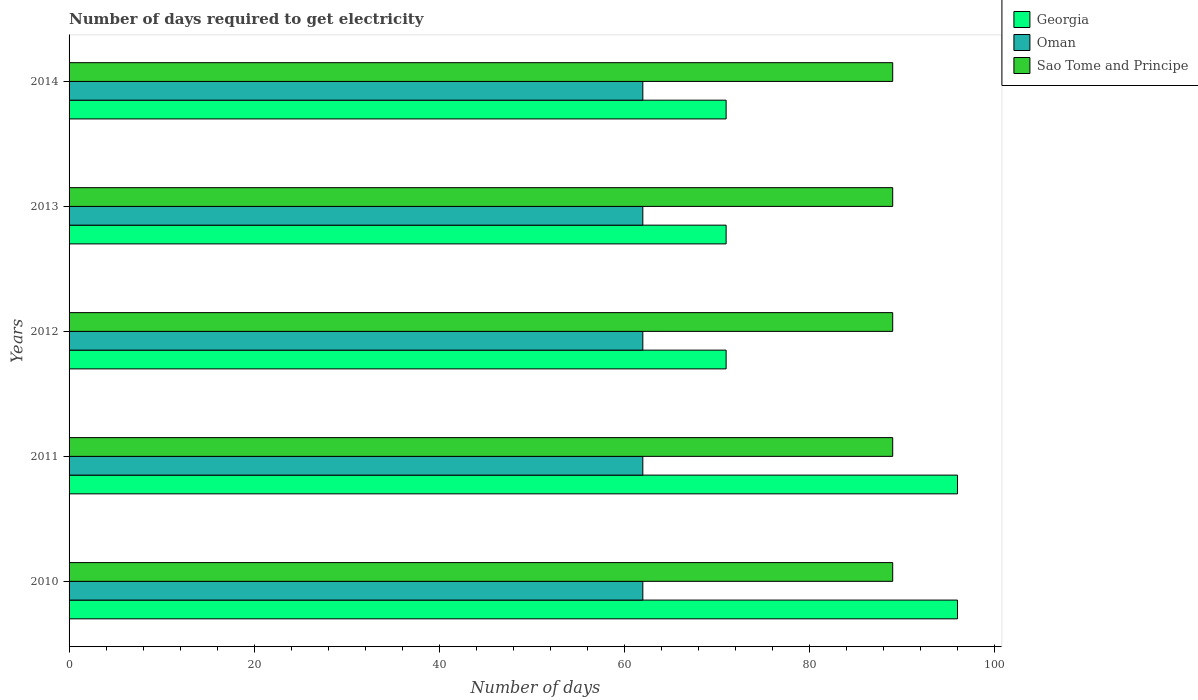How many groups of bars are there?
Keep it short and to the point. 5. Are the number of bars per tick equal to the number of legend labels?
Give a very brief answer. Yes. Are the number of bars on each tick of the Y-axis equal?
Ensure brevity in your answer.  Yes. In how many cases, is the number of bars for a given year not equal to the number of legend labels?
Make the answer very short. 0. What is the number of days required to get electricity in in Sao Tome and Principe in 2010?
Give a very brief answer. 89. Across all years, what is the maximum number of days required to get electricity in in Georgia?
Offer a terse response. 96. Across all years, what is the minimum number of days required to get electricity in in Sao Tome and Principe?
Your answer should be compact. 89. In which year was the number of days required to get electricity in in Georgia maximum?
Your answer should be very brief. 2010. In which year was the number of days required to get electricity in in Georgia minimum?
Offer a terse response. 2012. What is the total number of days required to get electricity in in Sao Tome and Principe in the graph?
Your answer should be very brief. 445. What is the difference between the number of days required to get electricity in in Georgia in 2013 and the number of days required to get electricity in in Oman in 2012?
Provide a short and direct response. 9. What is the average number of days required to get electricity in in Oman per year?
Your response must be concise. 62. In the year 2012, what is the difference between the number of days required to get electricity in in Sao Tome and Principe and number of days required to get electricity in in Oman?
Ensure brevity in your answer.  27. In how many years, is the number of days required to get electricity in in Sao Tome and Principe greater than 44 days?
Your response must be concise. 5. Is the number of days required to get electricity in in Sao Tome and Principe in 2012 less than that in 2013?
Your answer should be compact. No. What is the difference between the highest and the lowest number of days required to get electricity in in Oman?
Your answer should be very brief. 0. In how many years, is the number of days required to get electricity in in Oman greater than the average number of days required to get electricity in in Oman taken over all years?
Offer a very short reply. 0. What does the 1st bar from the top in 2012 represents?
Keep it short and to the point. Sao Tome and Principe. What does the 2nd bar from the bottom in 2011 represents?
Give a very brief answer. Oman. What is the difference between two consecutive major ticks on the X-axis?
Provide a succinct answer. 20. Are the values on the major ticks of X-axis written in scientific E-notation?
Offer a terse response. No. Does the graph contain grids?
Your answer should be compact. No. How many legend labels are there?
Keep it short and to the point. 3. What is the title of the graph?
Your response must be concise. Number of days required to get electricity. Does "Venezuela" appear as one of the legend labels in the graph?
Give a very brief answer. No. What is the label or title of the X-axis?
Offer a terse response. Number of days. What is the Number of days of Georgia in 2010?
Make the answer very short. 96. What is the Number of days of Sao Tome and Principe in 2010?
Make the answer very short. 89. What is the Number of days in Georgia in 2011?
Keep it short and to the point. 96. What is the Number of days of Sao Tome and Principe in 2011?
Keep it short and to the point. 89. What is the Number of days of Georgia in 2012?
Your answer should be compact. 71. What is the Number of days of Oman in 2012?
Your answer should be compact. 62. What is the Number of days in Sao Tome and Principe in 2012?
Your response must be concise. 89. What is the Number of days of Oman in 2013?
Your answer should be compact. 62. What is the Number of days of Sao Tome and Principe in 2013?
Make the answer very short. 89. What is the Number of days of Oman in 2014?
Offer a very short reply. 62. What is the Number of days in Sao Tome and Principe in 2014?
Provide a short and direct response. 89. Across all years, what is the maximum Number of days in Georgia?
Make the answer very short. 96. Across all years, what is the maximum Number of days in Oman?
Give a very brief answer. 62. Across all years, what is the maximum Number of days of Sao Tome and Principe?
Provide a succinct answer. 89. Across all years, what is the minimum Number of days in Oman?
Your answer should be compact. 62. Across all years, what is the minimum Number of days in Sao Tome and Principe?
Offer a terse response. 89. What is the total Number of days of Georgia in the graph?
Provide a succinct answer. 405. What is the total Number of days of Oman in the graph?
Make the answer very short. 310. What is the total Number of days of Sao Tome and Principe in the graph?
Your answer should be very brief. 445. What is the difference between the Number of days of Oman in 2010 and that in 2011?
Ensure brevity in your answer.  0. What is the difference between the Number of days of Sao Tome and Principe in 2010 and that in 2011?
Give a very brief answer. 0. What is the difference between the Number of days in Georgia in 2010 and that in 2012?
Ensure brevity in your answer.  25. What is the difference between the Number of days in Oman in 2010 and that in 2012?
Give a very brief answer. 0. What is the difference between the Number of days of Sao Tome and Principe in 2010 and that in 2012?
Offer a terse response. 0. What is the difference between the Number of days of Oman in 2010 and that in 2013?
Keep it short and to the point. 0. What is the difference between the Number of days in Sao Tome and Principe in 2010 and that in 2013?
Provide a short and direct response. 0. What is the difference between the Number of days in Georgia in 2010 and that in 2014?
Offer a very short reply. 25. What is the difference between the Number of days in Sao Tome and Principe in 2010 and that in 2014?
Provide a succinct answer. 0. What is the difference between the Number of days of Oman in 2011 and that in 2012?
Your answer should be compact. 0. What is the difference between the Number of days of Sao Tome and Principe in 2011 and that in 2012?
Make the answer very short. 0. What is the difference between the Number of days in Georgia in 2011 and that in 2013?
Offer a very short reply. 25. What is the difference between the Number of days of Sao Tome and Principe in 2011 and that in 2013?
Offer a very short reply. 0. What is the difference between the Number of days of Sao Tome and Principe in 2011 and that in 2014?
Your response must be concise. 0. What is the difference between the Number of days of Georgia in 2012 and that in 2013?
Your answer should be very brief. 0. What is the difference between the Number of days of Georgia in 2012 and that in 2014?
Your response must be concise. 0. What is the difference between the Number of days of Sao Tome and Principe in 2012 and that in 2014?
Provide a succinct answer. 0. What is the difference between the Number of days in Oman in 2013 and that in 2014?
Your answer should be compact. 0. What is the difference between the Number of days in Oman in 2010 and the Number of days in Sao Tome and Principe in 2011?
Your answer should be compact. -27. What is the difference between the Number of days in Georgia in 2010 and the Number of days in Sao Tome and Principe in 2012?
Your answer should be compact. 7. What is the difference between the Number of days in Georgia in 2010 and the Number of days in Sao Tome and Principe in 2013?
Make the answer very short. 7. What is the difference between the Number of days of Georgia in 2011 and the Number of days of Oman in 2012?
Make the answer very short. 34. What is the difference between the Number of days of Oman in 2011 and the Number of days of Sao Tome and Principe in 2012?
Your answer should be very brief. -27. What is the difference between the Number of days of Oman in 2011 and the Number of days of Sao Tome and Principe in 2013?
Offer a very short reply. -27. What is the difference between the Number of days in Georgia in 2012 and the Number of days in Oman in 2014?
Make the answer very short. 9. What is the difference between the Number of days in Georgia in 2012 and the Number of days in Sao Tome and Principe in 2014?
Offer a terse response. -18. What is the difference between the Number of days in Oman in 2013 and the Number of days in Sao Tome and Principe in 2014?
Your response must be concise. -27. What is the average Number of days in Sao Tome and Principe per year?
Make the answer very short. 89. In the year 2010, what is the difference between the Number of days of Georgia and Number of days of Sao Tome and Principe?
Keep it short and to the point. 7. In the year 2011, what is the difference between the Number of days of Georgia and Number of days of Sao Tome and Principe?
Provide a short and direct response. 7. In the year 2013, what is the difference between the Number of days in Georgia and Number of days in Sao Tome and Principe?
Provide a short and direct response. -18. In the year 2013, what is the difference between the Number of days of Oman and Number of days of Sao Tome and Principe?
Provide a short and direct response. -27. What is the ratio of the Number of days of Georgia in 2010 to that in 2012?
Provide a short and direct response. 1.35. What is the ratio of the Number of days of Georgia in 2010 to that in 2013?
Provide a short and direct response. 1.35. What is the ratio of the Number of days in Oman in 2010 to that in 2013?
Your answer should be compact. 1. What is the ratio of the Number of days of Sao Tome and Principe in 2010 to that in 2013?
Give a very brief answer. 1. What is the ratio of the Number of days in Georgia in 2010 to that in 2014?
Provide a short and direct response. 1.35. What is the ratio of the Number of days in Oman in 2010 to that in 2014?
Provide a succinct answer. 1. What is the ratio of the Number of days in Georgia in 2011 to that in 2012?
Keep it short and to the point. 1.35. What is the ratio of the Number of days in Georgia in 2011 to that in 2013?
Your response must be concise. 1.35. What is the ratio of the Number of days of Oman in 2011 to that in 2013?
Ensure brevity in your answer.  1. What is the ratio of the Number of days in Georgia in 2011 to that in 2014?
Make the answer very short. 1.35. What is the ratio of the Number of days of Oman in 2011 to that in 2014?
Provide a succinct answer. 1. What is the ratio of the Number of days in Oman in 2012 to that in 2013?
Your answer should be very brief. 1. What is the ratio of the Number of days of Georgia in 2012 to that in 2014?
Ensure brevity in your answer.  1. What is the ratio of the Number of days of Sao Tome and Principe in 2012 to that in 2014?
Offer a terse response. 1. What is the ratio of the Number of days of Oman in 2013 to that in 2014?
Provide a short and direct response. 1. What is the difference between the highest and the second highest Number of days in Georgia?
Ensure brevity in your answer.  0. What is the difference between the highest and the second highest Number of days in Oman?
Keep it short and to the point. 0. What is the difference between the highest and the second highest Number of days in Sao Tome and Principe?
Your response must be concise. 0. What is the difference between the highest and the lowest Number of days of Georgia?
Your answer should be very brief. 25. What is the difference between the highest and the lowest Number of days in Oman?
Offer a terse response. 0. What is the difference between the highest and the lowest Number of days in Sao Tome and Principe?
Offer a terse response. 0. 